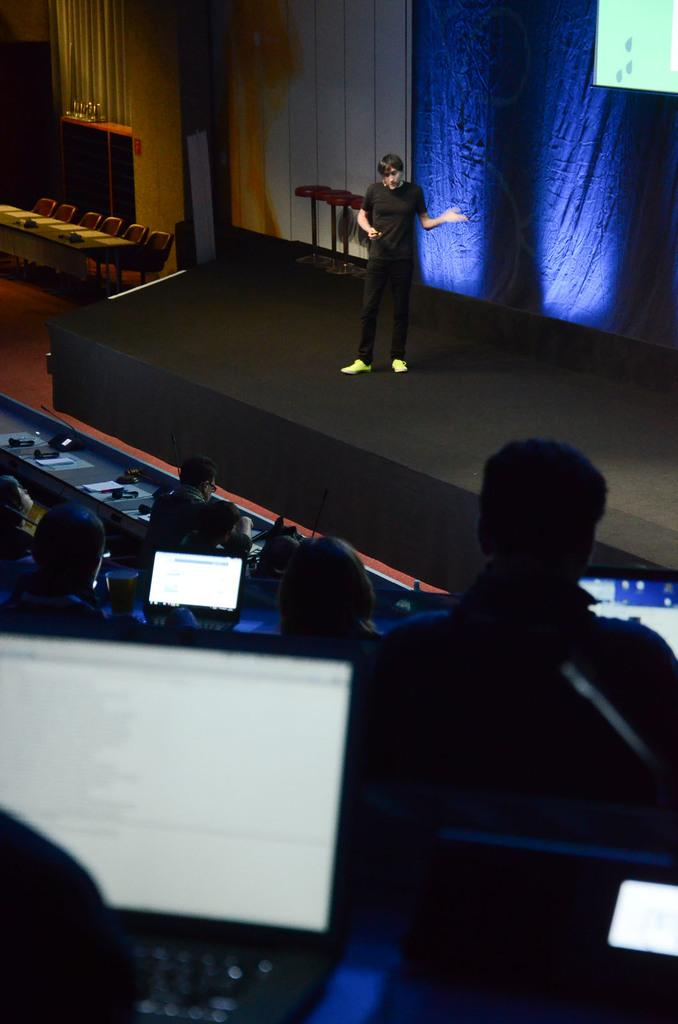How many people are in the image? There is a group of people in the image. What are some of the people doing in the image? Some people are seated on chairs, while a man is standing on a stage. What electronic devices can be seen in the image? There are laptops in the image. What type of backdrop is present in the image? There are curtains in the image. What type of furniture is present in the image? There are tables in the image. Who is the creator of the family in the image? There is no mention of a family in the image, and therefore no creator can be identified. 